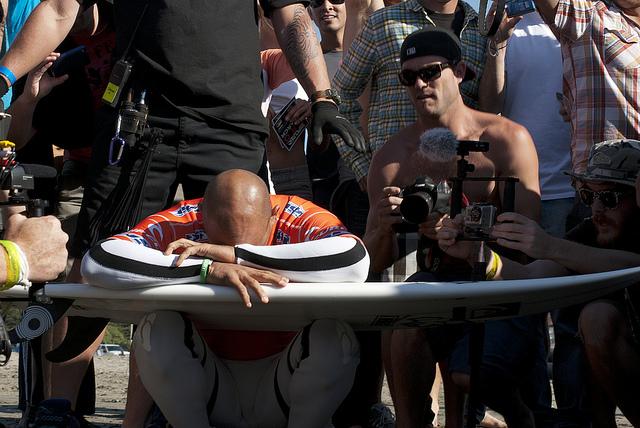Is the man asleep?
Write a very short answer. No. What is the man resting his head against?
Keep it brief. Surfboard. Why is this man's head down?
Answer briefly. Won. 